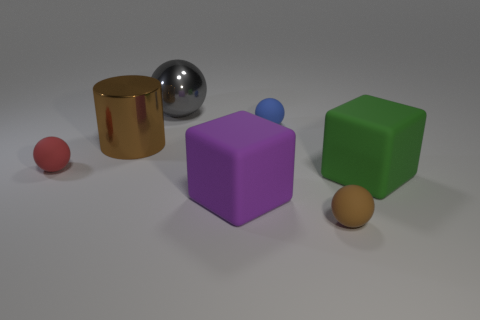What number of red matte objects have the same shape as the gray thing? In the image, there is 1 red matte object – a sphere – that shares the same shape as the gray object, which is also a sphere. 